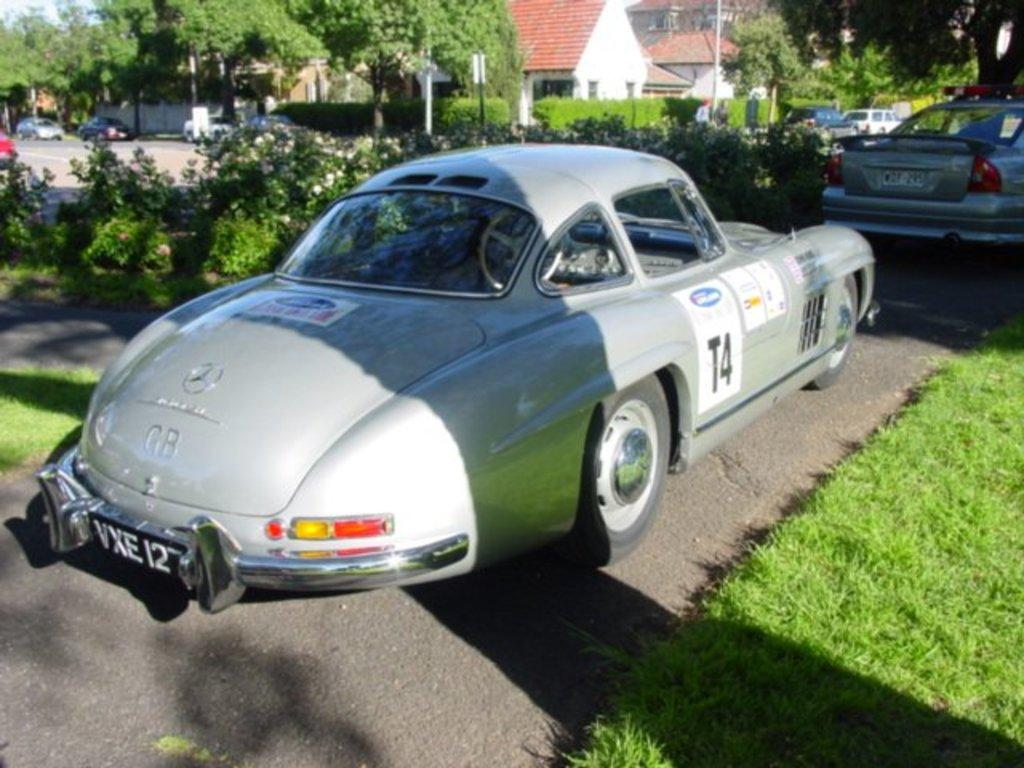What type of structures can be seen in the image? There are buildings in the image. What is moving on the road in the image? Motor vehicles are present on the road in the image. What type of vegetation is visible in the image? Plants, shrubs, and trees are visible in the image. What type of surface is visible in the image? Grass is visible in the image. What are the vertical structures present in the image? Street poles are present in the image. What type of signs are visible in the image? Information boards are present in the image. What part of the natural environment is visible in the image? The sky is visible in the image. What type of crack can be seen on the buildings in the image? There is no crack visible on the buildings in the image. What type of lock is present on the information boards in the image? There is no lock visible on the information boards in the image. 